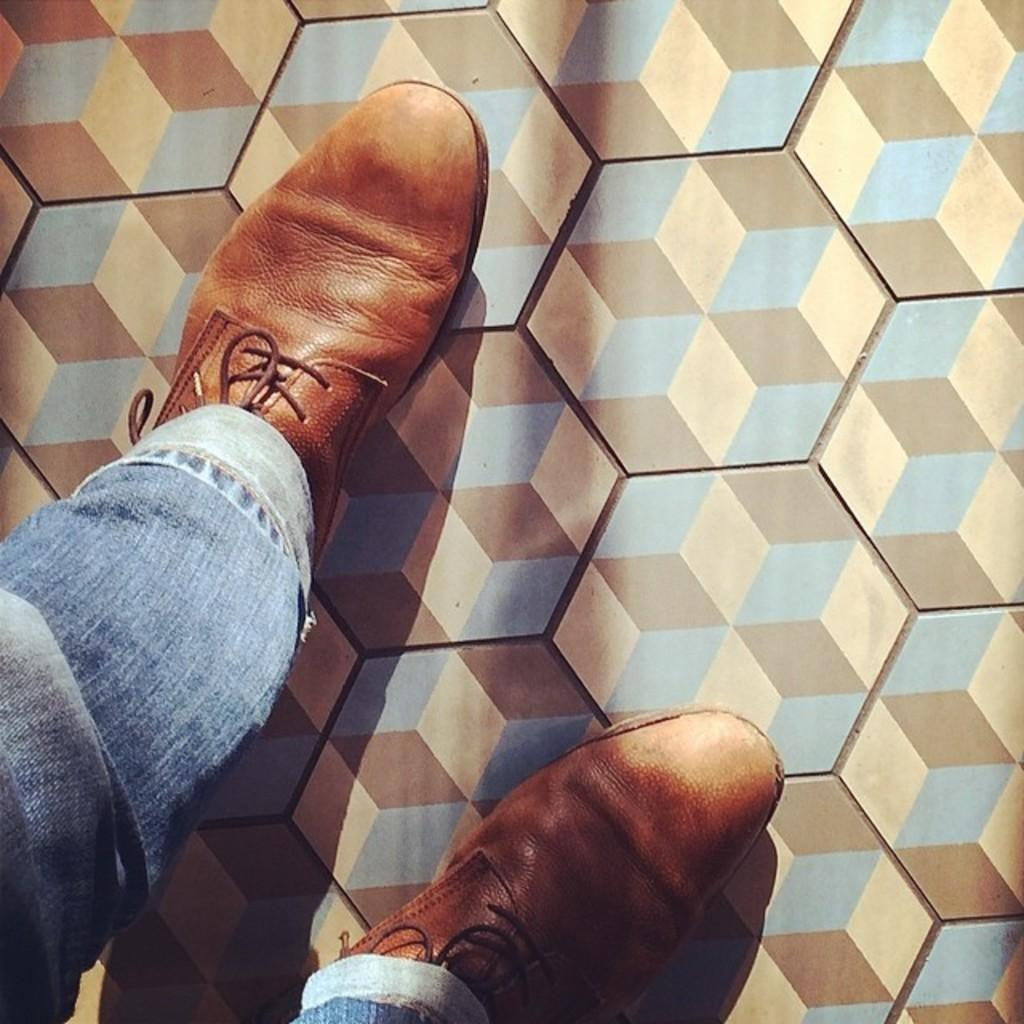What part of a person's body is visible in the image? The image shows a person's legs. What type of clothing is the person wearing on their legs? The person is wearing jeans. What type of footwear is the person wearing? The person is wearing shoes. What surface is the person standing on in the image? The person is standing on the floor. What type of tent can be seen in the background of the image? There is no tent present in the image; it only shows a person's legs. 